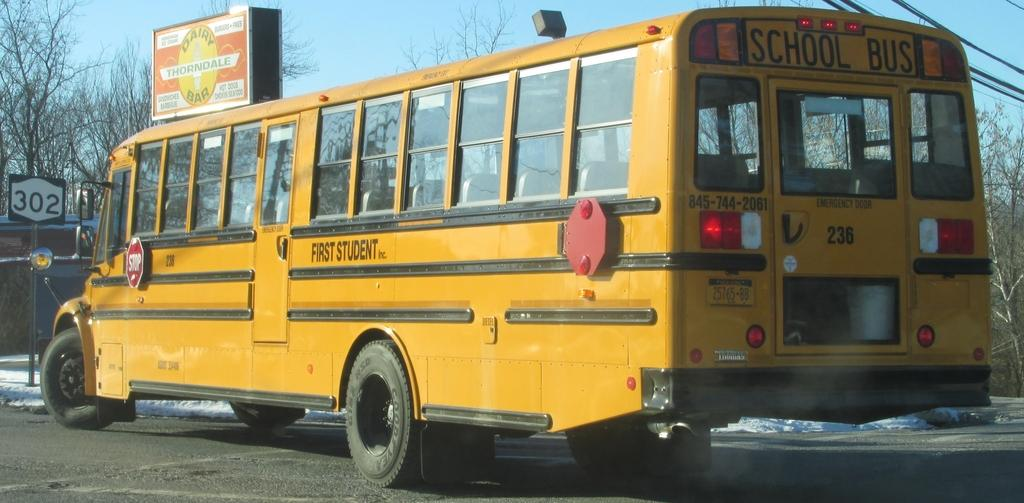What is the main subject in the foreground of the image? There is a bus in the foreground of the image. What is placed on the road in the foreground of the image? There is a board on the road in the foreground of the image. What can be seen in the background of the image? There are trees, poles, and the sky visible in the background of the image. Can you determine the time of day when the image was taken? The image was likely taken during the day, as the sky is visible and not dark. What type of voice can be heard coming from the bus in the image? There is no voice present in the image, as it is a still photograph and does not contain any audio. 